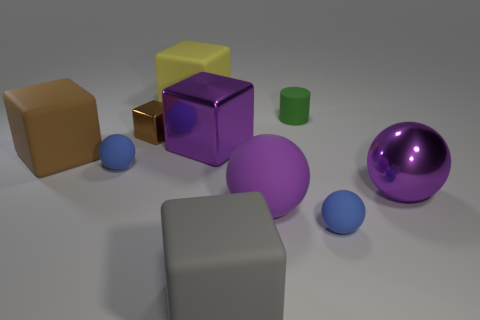Subtract all brown cubes. How many were subtracted if there are1brown cubes left? 1 Subtract all big purple rubber spheres. How many spheres are left? 3 Subtract all gray cylinders. How many brown blocks are left? 2 Subtract all blue spheres. How many spheres are left? 2 Subtract 1 cubes. How many cubes are left? 4 Subtract all yellow balls. Subtract all yellow cylinders. How many balls are left? 4 Add 4 big gray things. How many big gray things are left? 5 Add 7 shiny objects. How many shiny objects exist? 10 Subtract 0 cyan balls. How many objects are left? 10 Subtract all cylinders. How many objects are left? 9 